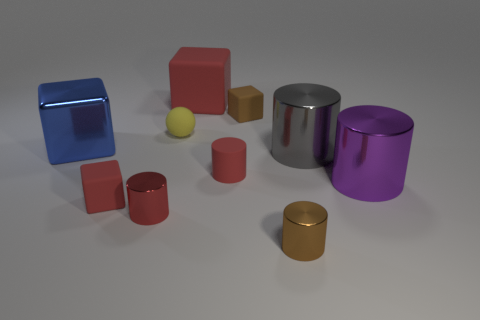Subtract all gray cylinders. How many cylinders are left? 4 Subtract 1 cylinders. How many cylinders are left? 4 Subtract all blue cubes. How many cubes are left? 3 Subtract all purple blocks. Subtract all purple spheres. How many blocks are left? 4 Subtract all balls. How many objects are left? 9 Subtract all small red objects. Subtract all small red shiny balls. How many objects are left? 7 Add 8 tiny brown metal things. How many tiny brown metal things are left? 9 Add 4 small red rubber objects. How many small red rubber objects exist? 6 Subtract 1 yellow spheres. How many objects are left? 9 